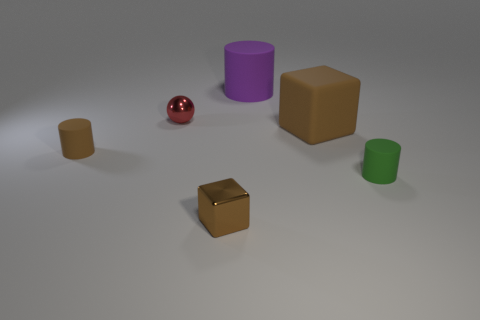What number of blocks are the same material as the brown cylinder?
Give a very brief answer. 1. There is a large matte object that is in front of the purple cylinder; what is its shape?
Your answer should be very brief. Cube. Is the big cube made of the same material as the brown cube that is left of the purple thing?
Provide a short and direct response. No. Is there a tiny blue shiny thing?
Keep it short and to the point. No. Are there any green rubber objects that are in front of the small green rubber thing right of the large thing that is to the left of the large brown rubber object?
Your answer should be compact. No. What number of tiny objects are either purple matte objects or gray spheres?
Offer a very short reply. 0. There is a metal cube that is the same size as the brown cylinder; what is its color?
Make the answer very short. Brown. What number of small brown metallic blocks are behind the tiny green rubber object?
Your answer should be compact. 0. Are there any objects that have the same material as the tiny block?
Give a very brief answer. Yes. The tiny rubber object that is the same color as the large matte block is what shape?
Offer a very short reply. Cylinder. 